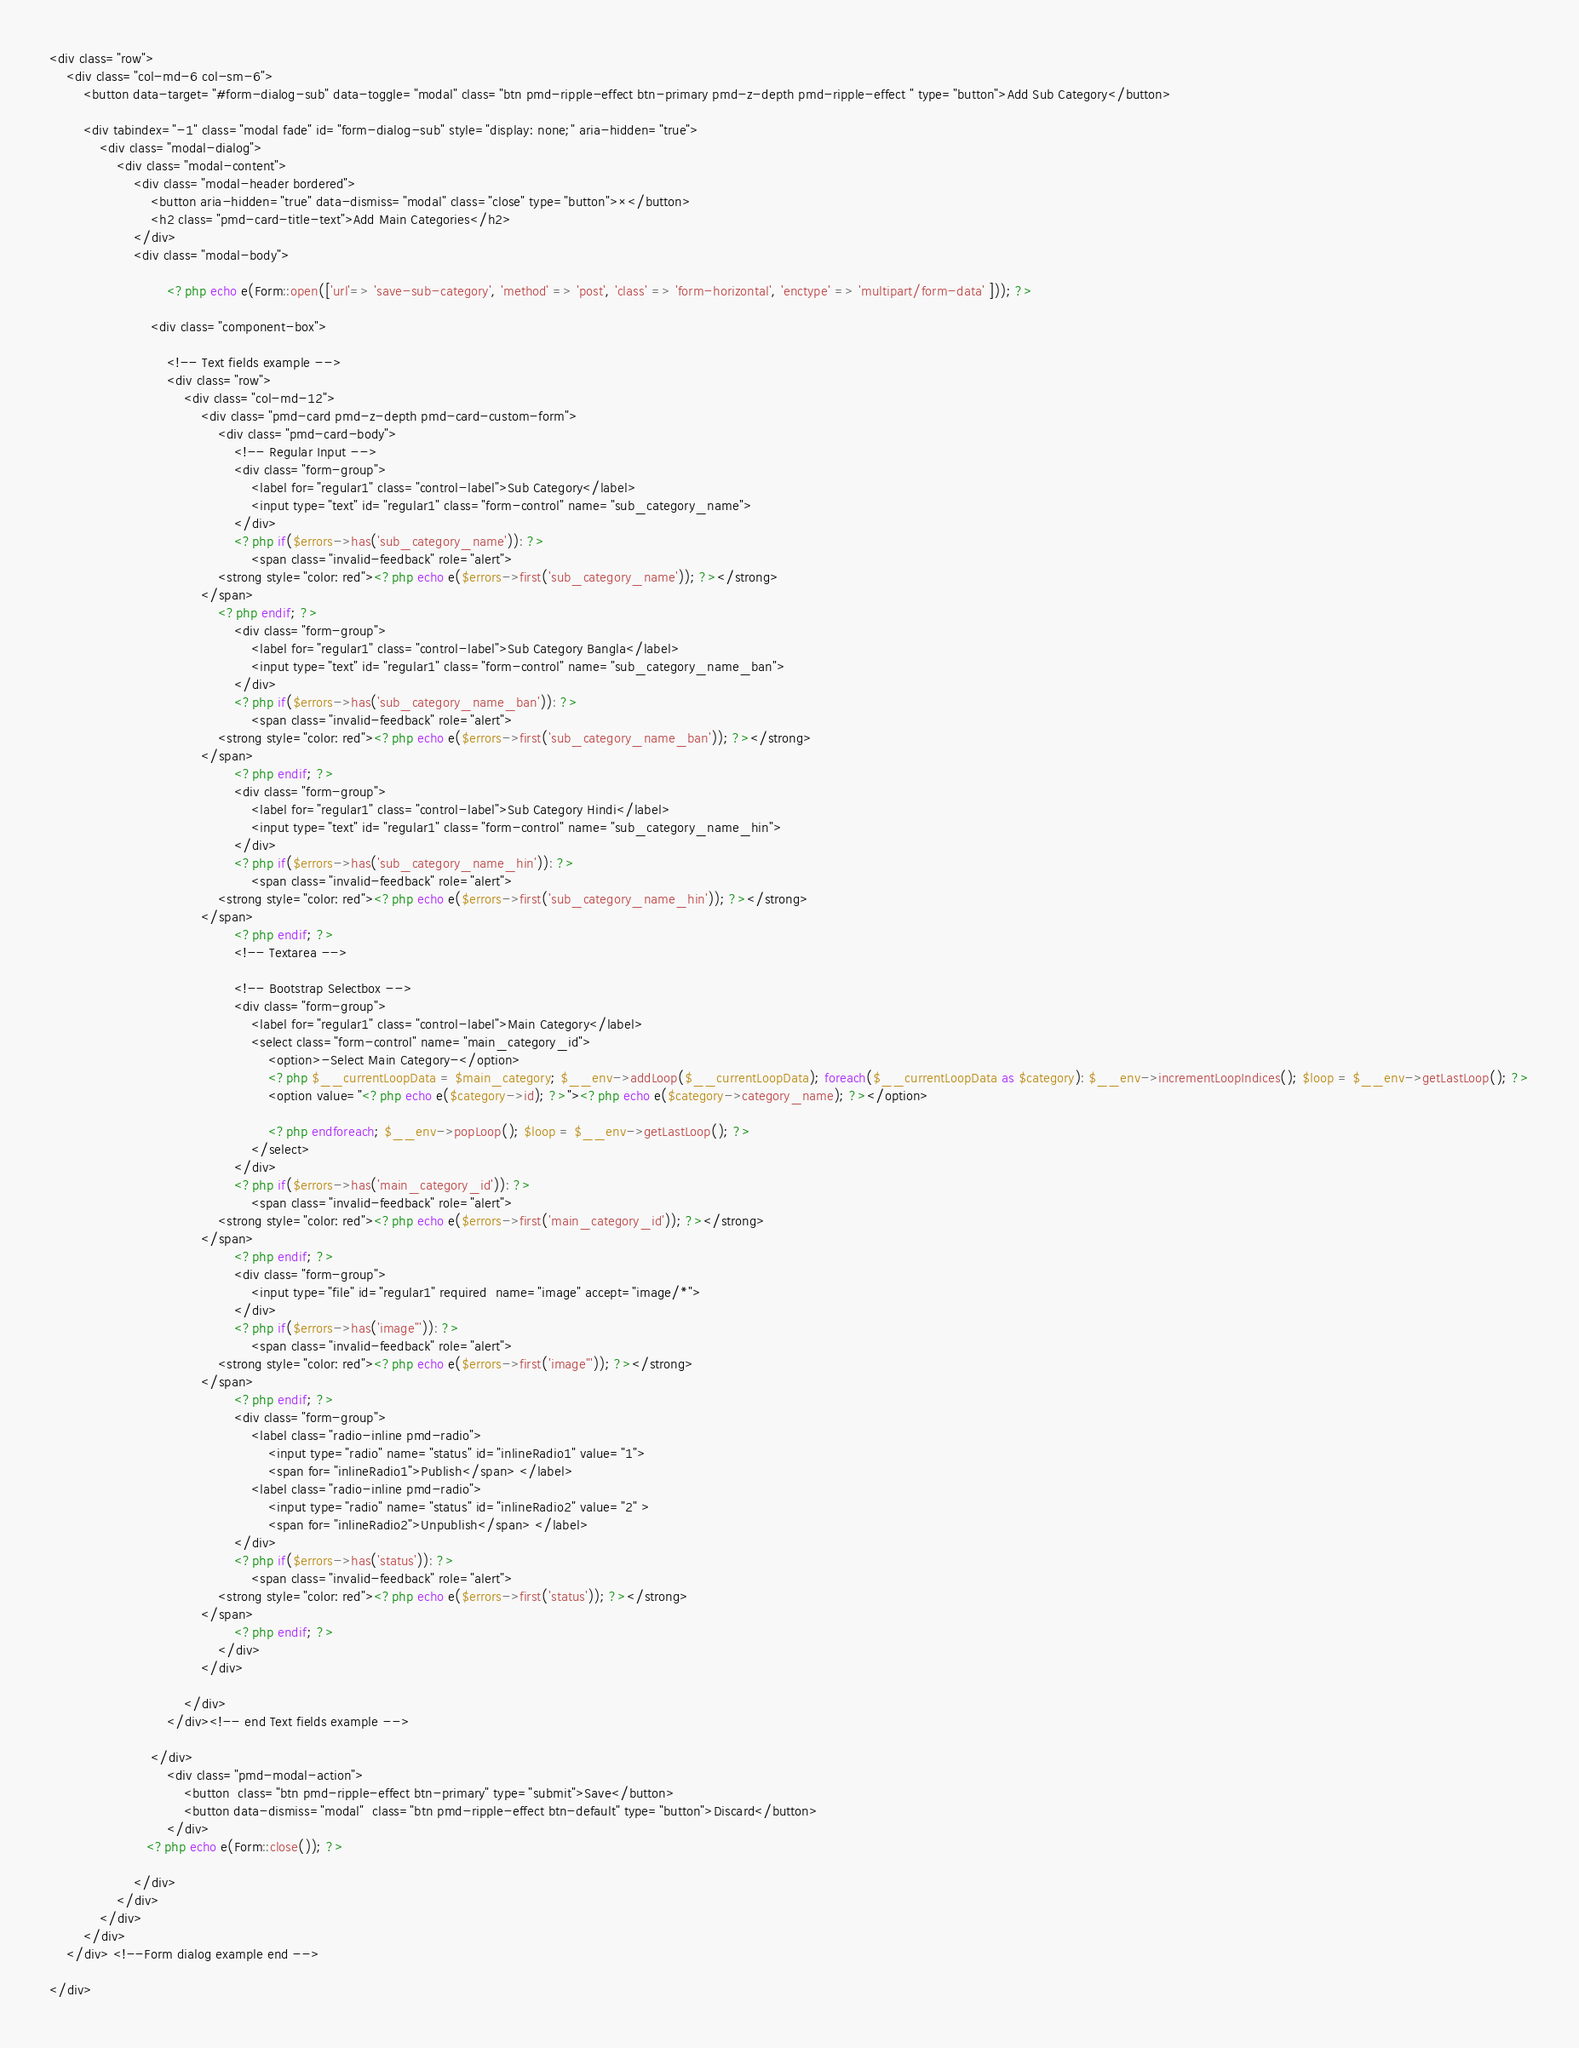<code> <loc_0><loc_0><loc_500><loc_500><_PHP_><div class="row">
    <div class="col-md-6 col-sm-6">
        <button data-target="#form-dialog-sub" data-toggle="modal" class="btn pmd-ripple-effect btn-primary pmd-z-depth pmd-ripple-effect " type="button">Add Sub Category</button>

        <div tabindex="-1" class="modal fade" id="form-dialog-sub" style="display: none;" aria-hidden="true">
            <div class="modal-dialog">
                <div class="modal-content">
                    <div class="modal-header bordered">
                        <button aria-hidden="true" data-dismiss="modal" class="close" type="button">×</button>
                        <h2 class="pmd-card-title-text">Add Main Categories</h2>
                    </div>
                    <div class="modal-body">

                            <?php echo e(Form::open(['url'=> 'save-sub-category', 'method' => 'post', 'class' => 'form-horizontal', 'enctype' => 'multipart/form-data' ])); ?>

                        <div class="component-box">

                            <!-- Text fields example -->
                            <div class="row">
                                <div class="col-md-12">
                                    <div class="pmd-card pmd-z-depth pmd-card-custom-form">
                                        <div class="pmd-card-body">
                                            <!-- Regular Input -->
                                            <div class="form-group">
                                                <label for="regular1" class="control-label">Sub Category</label>
                                                <input type="text" id="regular1" class="form-control" name="sub_category_name">
                                            </div>
                                            <?php if($errors->has('sub_category_name')): ?>
                                                <span class="invalid-feedback" role="alert">
                                        <strong style="color: red"><?php echo e($errors->first('sub_category_name')); ?></strong>
                                    </span>
                                        <?php endif; ?>
                                            <div class="form-group">
                                                <label for="regular1" class="control-label">Sub Category Bangla</label>
                                                <input type="text" id="regular1" class="form-control" name="sub_category_name_ban">
                                            </div>
                                            <?php if($errors->has('sub_category_name_ban')): ?>
                                                <span class="invalid-feedback" role="alert">
                                        <strong style="color: red"><?php echo e($errors->first('sub_category_name_ban')); ?></strong>
                                    </span>
                                            <?php endif; ?>
                                            <div class="form-group">
                                                <label for="regular1" class="control-label">Sub Category Hindi</label>
                                                <input type="text" id="regular1" class="form-control" name="sub_category_name_hin">
                                            </div>
                                            <?php if($errors->has('sub_category_name_hin')): ?>
                                                <span class="invalid-feedback" role="alert">
                                        <strong style="color: red"><?php echo e($errors->first('sub_category_name_hin')); ?></strong>
                                    </span>
                                            <?php endif; ?>
                                            <!-- Textarea -->

                                            <!-- Bootstrap Selectbox -->
                                            <div class="form-group">
                                                <label for="regular1" class="control-label">Main Category</label>
                                                <select class="form-control" name="main_category_id">
                                                    <option>-Select Main Category-</option>
                                                    <?php $__currentLoopData = $main_category; $__env->addLoop($__currentLoopData); foreach($__currentLoopData as $category): $__env->incrementLoopIndices(); $loop = $__env->getLastLoop(); ?>
                                                    <option value="<?php echo e($category->id); ?>"><?php echo e($category->category_name); ?></option>

                                                    <?php endforeach; $__env->popLoop(); $loop = $__env->getLastLoop(); ?>
                                                </select>
                                            </div>
                                            <?php if($errors->has('main_category_id')): ?>
                                                <span class="invalid-feedback" role="alert">
                                        <strong style="color: red"><?php echo e($errors->first('main_category_id')); ?></strong>
                                    </span>
                                            <?php endif; ?>
                                            <div class="form-group">
                                                <input type="file" id="regular1" required  name="image" accept="image/*">
                                            </div>
                                            <?php if($errors->has('image"')): ?>
                                                <span class="invalid-feedback" role="alert">
                                        <strong style="color: red"><?php echo e($errors->first('image"')); ?></strong>
                                    </span>
                                            <?php endif; ?>
                                            <div class="form-group">
                                                <label class="radio-inline pmd-radio">
                                                    <input type="radio" name="status" id="inlineRadio1" value="1">
                                                    <span for="inlineRadio1">Publish</span> </label>
                                                <label class="radio-inline pmd-radio">
                                                    <input type="radio" name="status" id="inlineRadio2" value="2" >
                                                    <span for="inlineRadio2">Unpublish</span> </label>
                                            </div>
                                            <?php if($errors->has('status')): ?>
                                                <span class="invalid-feedback" role="alert">
                                        <strong style="color: red"><?php echo e($errors->first('status')); ?></strong>
                                    </span>
                                            <?php endif; ?>
                                        </div>
                                    </div>

                                </div>
                            </div><!-- end Text fields example -->

                        </div>
                            <div class="pmd-modal-action">
                                <button  class="btn pmd-ripple-effect btn-primary" type="submit">Save</button>
                                <button data-dismiss="modal"  class="btn pmd-ripple-effect btn-default" type="button">Discard</button>
                            </div>
                       <?php echo e(Form::close()); ?>

                    </div>
                </div>
            </div>
        </div>
    </div> <!--Form dialog example end -->

</div>
</code> 